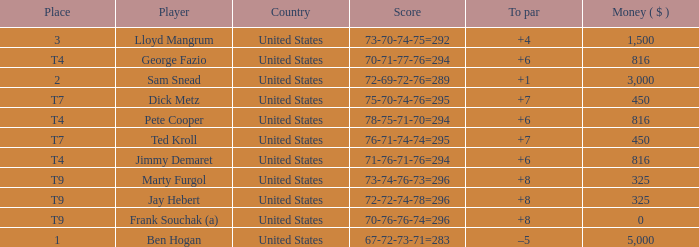How much was paid to the player whose score was 70-71-77-76=294? 816.0. 